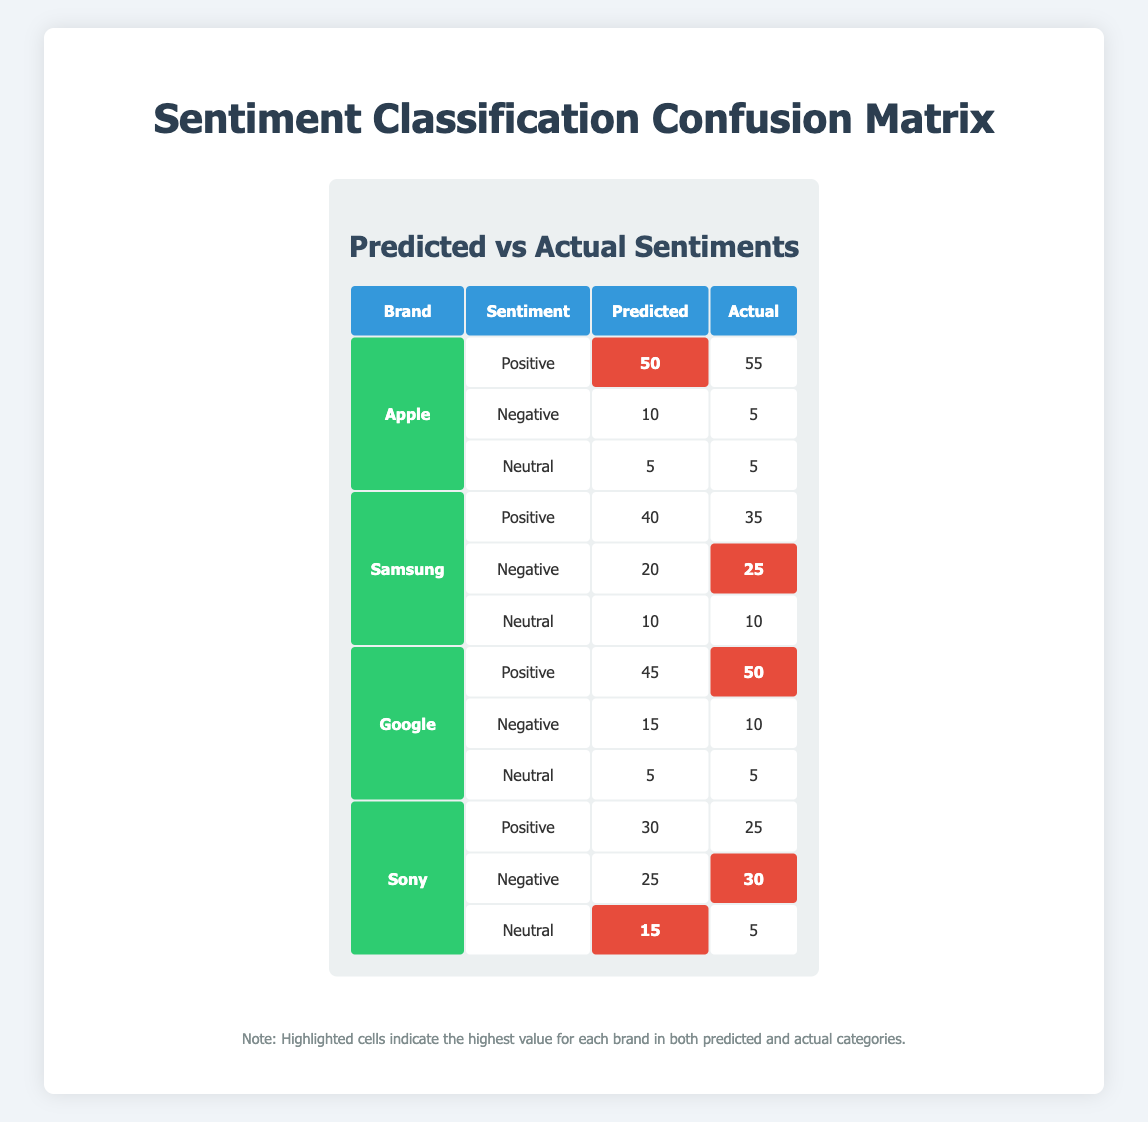What is the predicted number of positive sentiments for Apple? The table shows that the predicted number of positive sentiments for Apple is listed under the "Predicted" column for Positive sentiment. That value is 50.
Answer: 50 What is the actual number of negative sentiments for Google? In the table, the actual number of negative sentiments for Google is listed under the "Actual" column for Negative sentiment, which is 10.
Answer: 10 How many total sentiments were predicted for Samsung? To calculate the total sentiments predicted for Samsung, we need to add the predicted values for all sentiments: Positive (40) + Negative (20) + Neutral (10) = 70.
Answer: 70 Did Sony have more predicted negative sentiments than actual negative sentiments? For Sony, the predicted negative sentiments is 25, while the actual negative sentiments is 30. Since 25 is less than 30, the answer is no.
Answer: No What is the difference between predicted and actual positive sentiments for Google? For Google, the predicted positive sentiment is 45, and the actual positive sentiment is 50. The difference is calculated as follows: 50 - 45 = 5.
Answer: 5 Which brand had the highest predicted negative sentiments? Reviewing the table, we compare the predicted negative sentiments for Apple (10), Samsung (20), Google (15), and Sony (25). Sony has the highest predicted negative sentiments at 25.
Answer: Sony What is the average number of neutral sentiments predicted across all brands? The neutral predictions are: Apple (5), Samsung (10), Google (5), and Sony (15). Summing these values gives 5 + 10 + 5 + 15 = 35. Then, divide by the number of brands (4): 35 / 4 = 8.75.
Answer: 8.75 How does the predicted sentiment for positive compare to the actual sentiment for neutral in Samsung? For Samsung, the predicted positive sentiment is 40, whereas the actual neutral sentiment is 10. The predicted value (40) is greater than the actual (10).
Answer: Predicted is greater Is the predicted neutral sentiment for Apple equal to the actual neutral sentiment for Apple? The predicted neutral sentiment for Apple is 5, and the actual neutral sentiment is also 5. Since both values are the same, the answer is yes.
Answer: Yes 